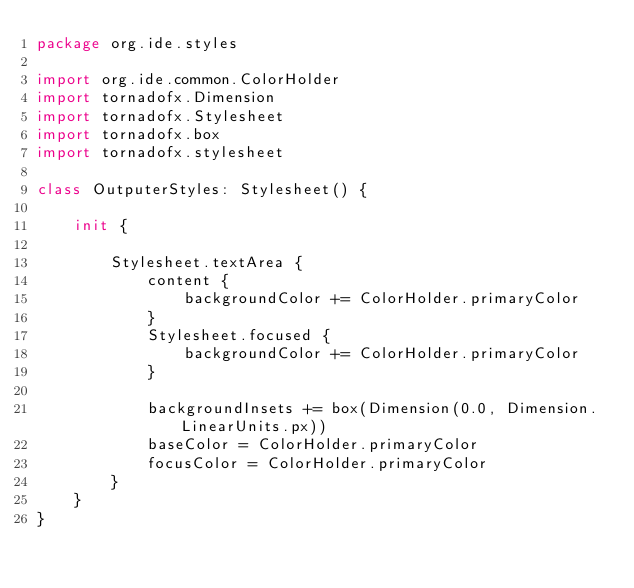Convert code to text. <code><loc_0><loc_0><loc_500><loc_500><_Kotlin_>package org.ide.styles

import org.ide.common.ColorHolder
import tornadofx.Dimension
import tornadofx.Stylesheet
import tornadofx.box
import tornadofx.stylesheet

class OutputerStyles: Stylesheet() {

    init {

        Stylesheet.textArea {
            content {
                backgroundColor += ColorHolder.primaryColor
            }
            Stylesheet.focused {
                backgroundColor += ColorHolder.primaryColor
            }

            backgroundInsets += box(Dimension(0.0, Dimension.LinearUnits.px))
            baseColor = ColorHolder.primaryColor
            focusColor = ColorHolder.primaryColor
        }
    }
}</code> 